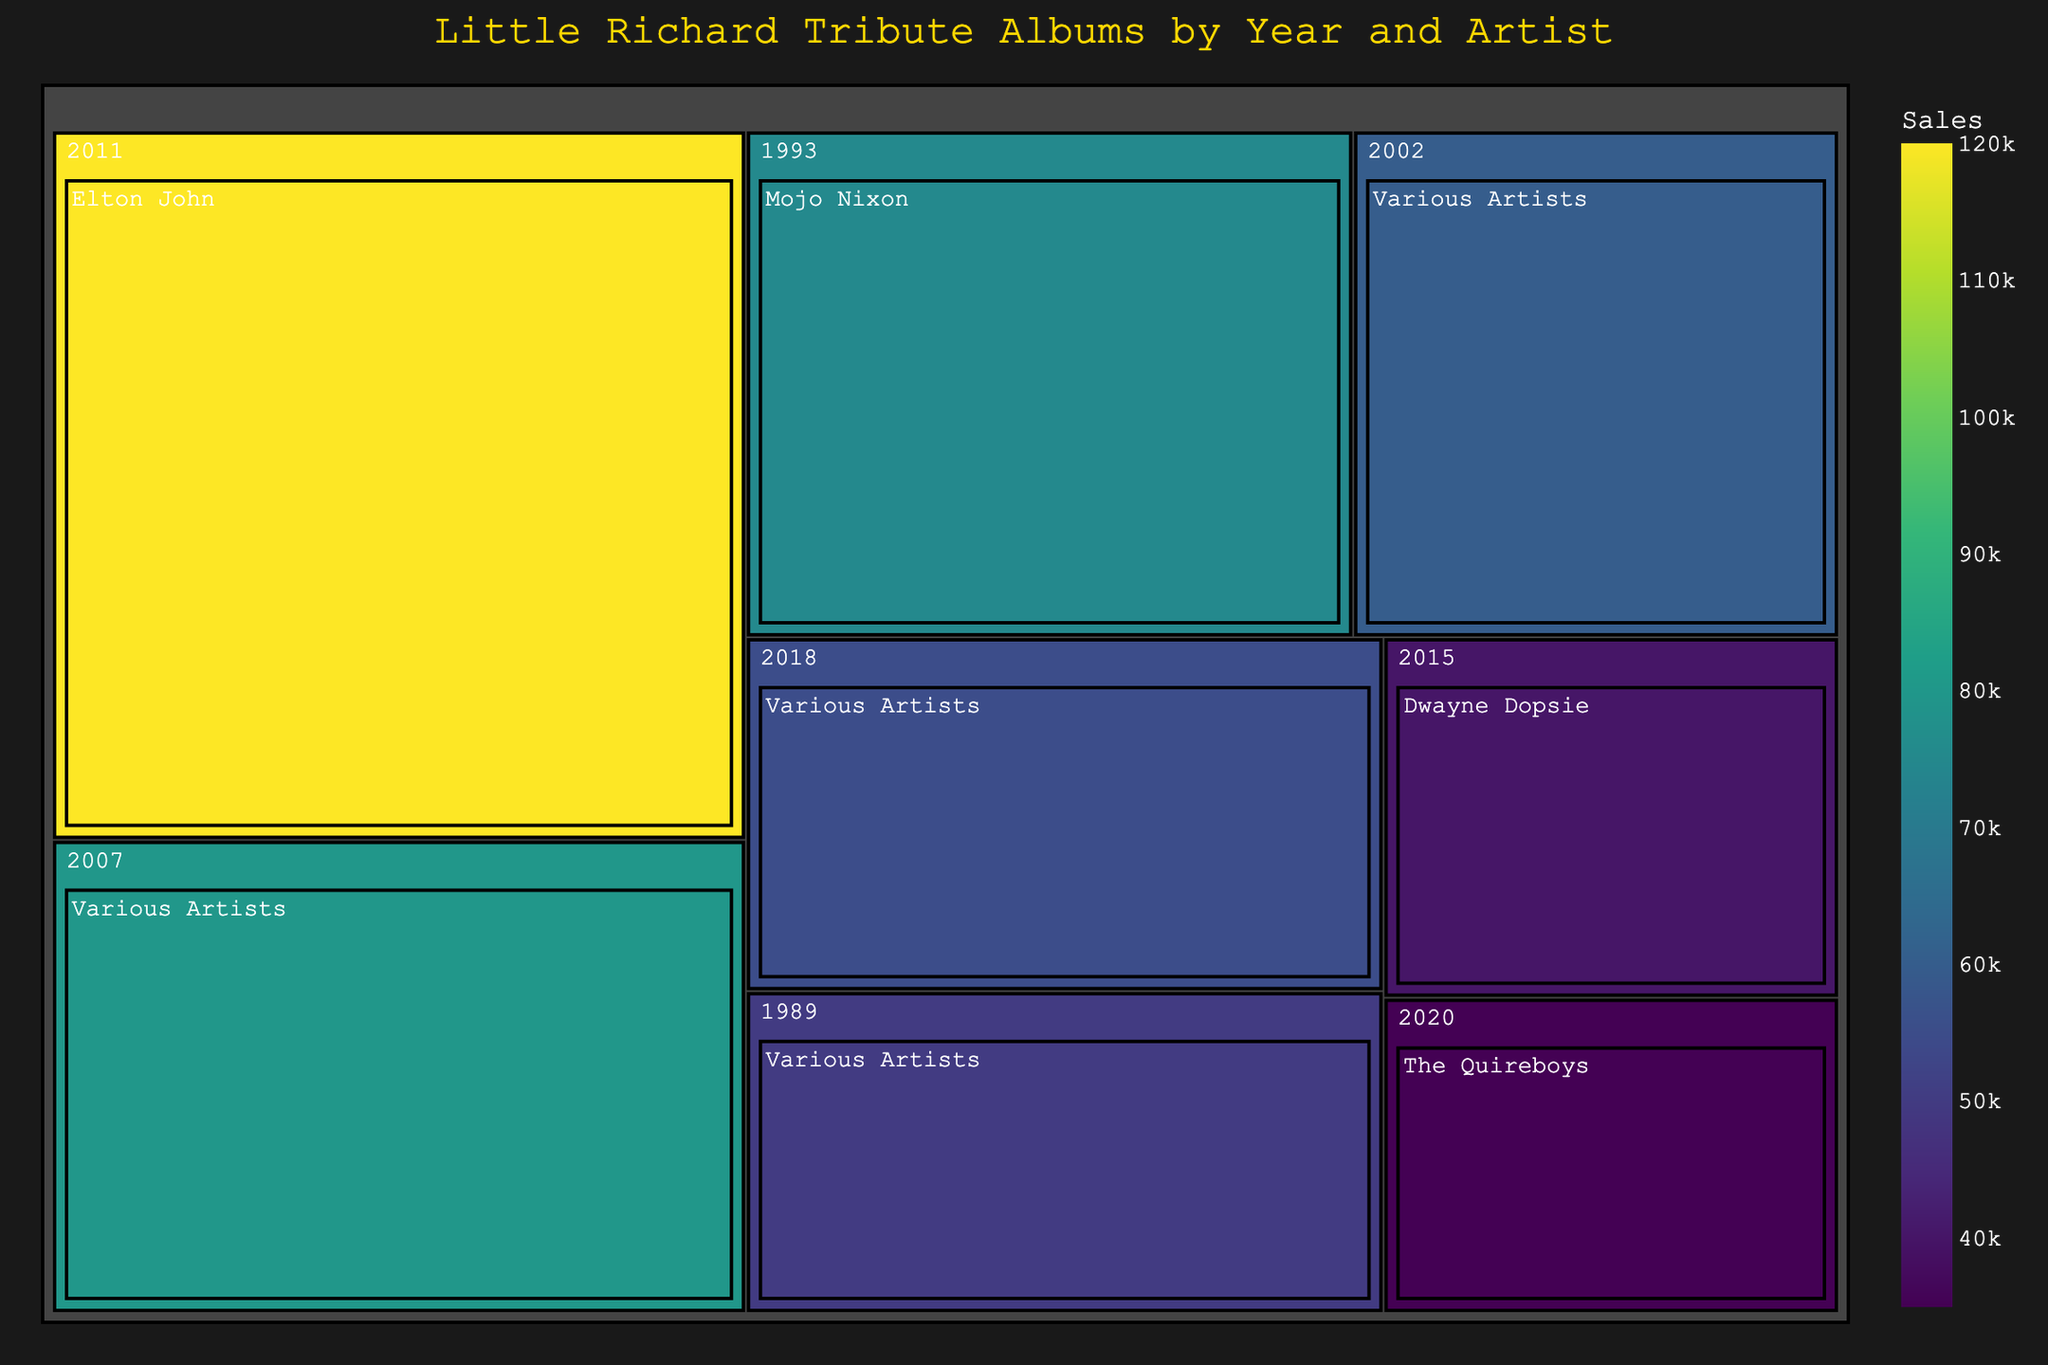what is the title of the plot? The title is positioned at the top center of the treemap. From the visual, the title "Little Richard Tribute Albums by Year and Artist" is clearly visible.
Answer: Little Richard Tribute Albums by Year and Artist What is the color scheme used in the treemap? The treemap uses a "Viridis" color scale, which transitions through shades of purple, green, and yellow. This gives a clear visual distinction based on sales values.
Answer: Viridis Which artist’s album had the highest sales? The sales can be interpreted through the size and color intensity of the blocks in the treemap. The darkest and largest block corresponds to Elton John's album in 2011 with sales of 120,000.
Answer: Elton John How many tribute albums were released by Various Artists? By identifying the blocks labeled "Various Artists" and counting them, we see there are 4 albums in the treemap.
Answer: 4 What year had the most tribute albums released? Grouping the blocks by year in the treemap reveals that 2020, 2018, and 2002 each had two albums.
Answer: 2020, 2018, 2002 (each had 2 albums) What is the total sales of tribute albums released in 2002? Each year is grouped, and the total sales are summed. In 2002, there is only one album by Various Artists with 60,000 sales.
Answer: 60,000 Which year has the highest average sales across tribute albums? Calculate the average sales for each year and compare. Only 2011 has 1 album with 120,000 sales, which is the highest average.
Answer: 2011 Which album has the lowest sales and who is the artist? The block with the smallest size corresponds to the album by The Quireboys in 2020 with 35,000 sales.
Answer: White Faced and Jaded: A Tribute To Little Richard by The Quireboys What’s the difference in sales between the highest and lowest-selling albums? The highest sales are 120,000 (Elton John, 2011) and the lowest is 35,000 (The Quireboys, 2020). The difference is 120,000 - 35,000 = 85,000.
Answer: 85,000 